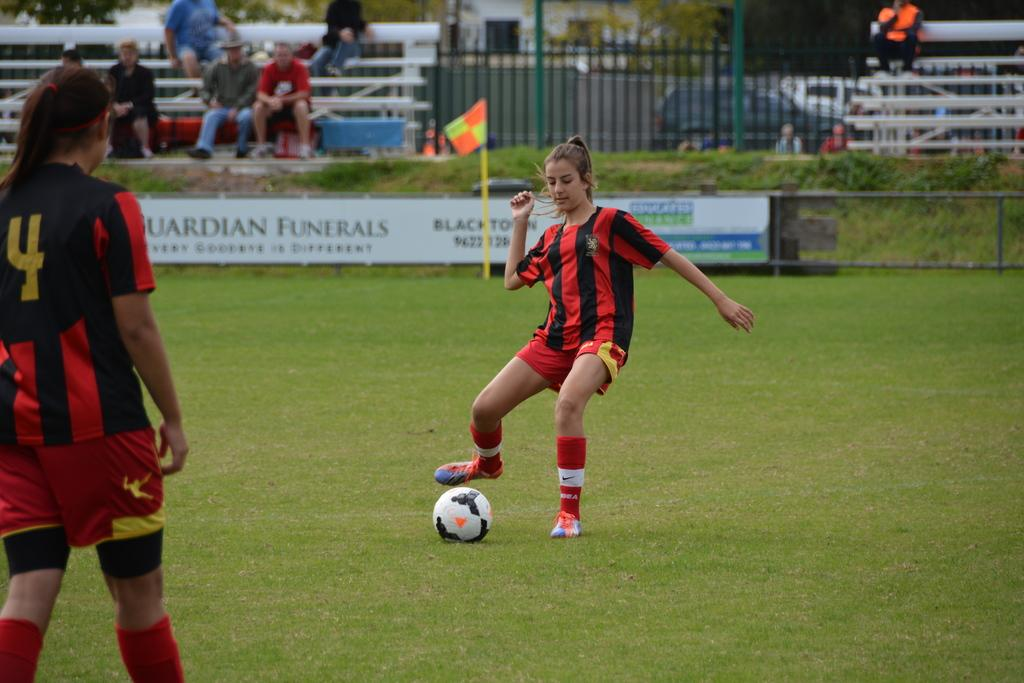<image>
Summarize the visual content of the image. A soccer game with two women in red and black jersey with one having the number 4 on the back of her jersey. 